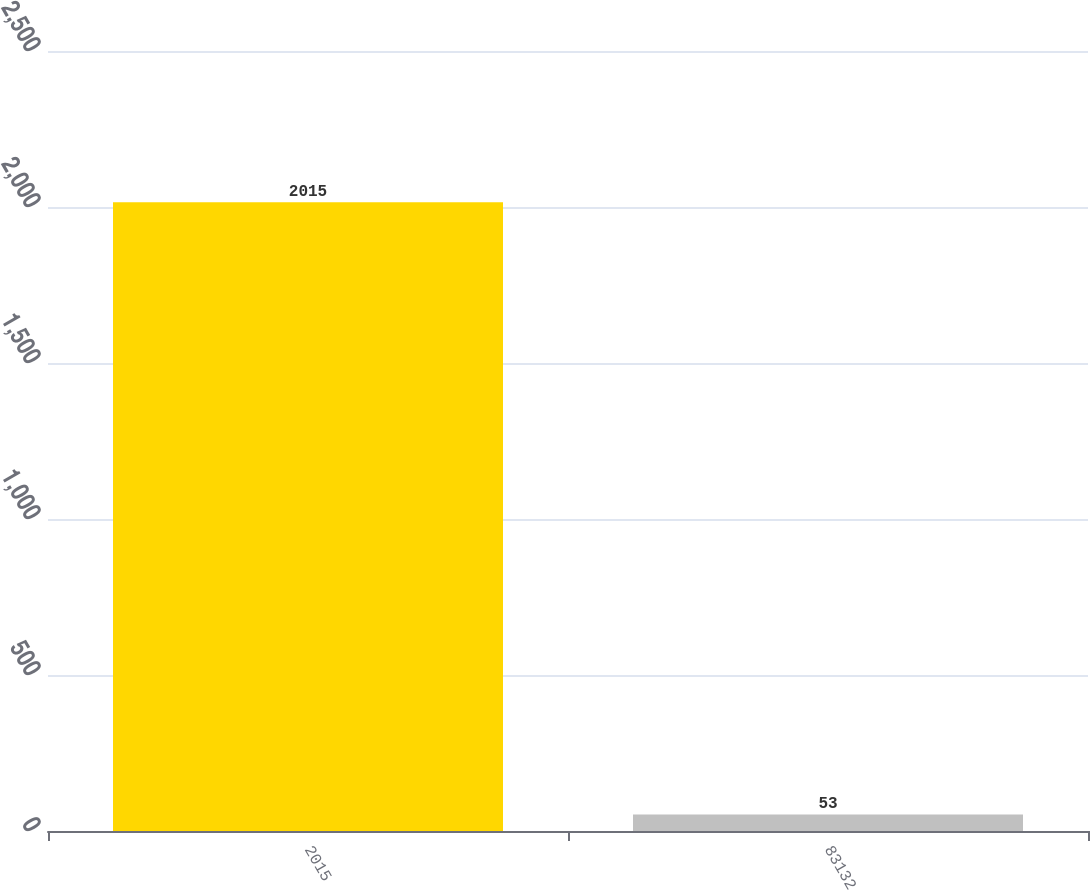Convert chart. <chart><loc_0><loc_0><loc_500><loc_500><bar_chart><fcel>2015<fcel>83132<nl><fcel>2015<fcel>53<nl></chart> 